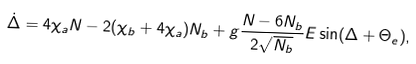<formula> <loc_0><loc_0><loc_500><loc_500>\dot { \Delta } = 4 \chi _ { a } N - 2 ( \chi _ { b } + 4 \chi _ { a } ) N _ { b } + g \frac { N - 6 N _ { b } } { 2 \sqrt { N _ { b } } } E \sin ( \Delta + \Theta _ { e } ) ,</formula> 